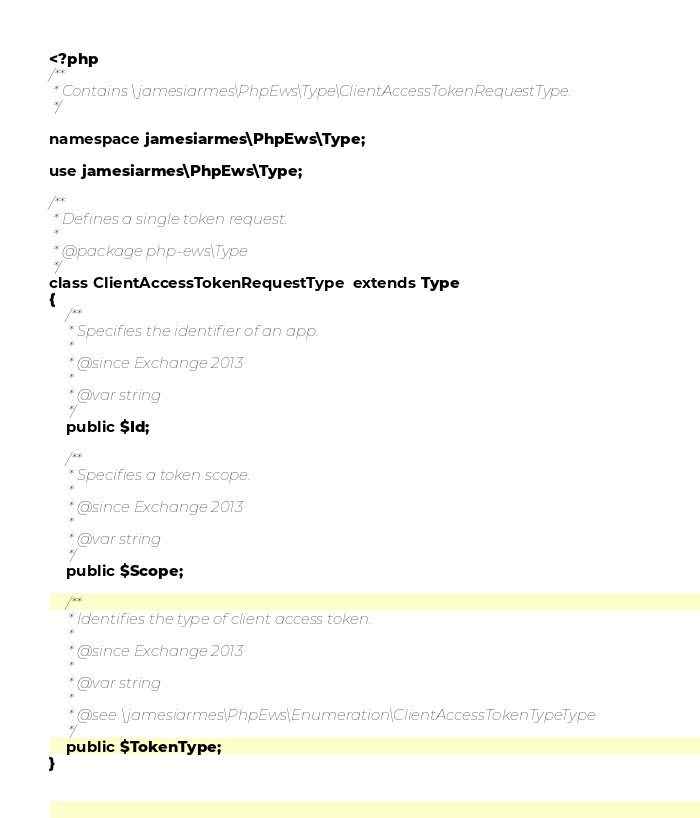<code> <loc_0><loc_0><loc_500><loc_500><_PHP_><?php
/**
 * Contains \jamesiarmes\PhpEws\Type\ClientAccessTokenRequestType.
 */

namespace jamesiarmes\PhpEws\Type;

use jamesiarmes\PhpEws\Type;

/**
 * Defines a single token request.
 *
 * @package php-ews\Type
 */
class ClientAccessTokenRequestType extends Type
{
    /**
     * Specifies the identifier of an app.
     *
     * @since Exchange 2013
     *
     * @var string
     */
    public $Id;

    /**
     * Specifies a token scope.
     *
     * @since Exchange 2013
     *
     * @var string
     */
    public $Scope;

    /**
     * Identifies the type of client access token.
     *
     * @since Exchange 2013
     *
     * @var string
     *
     * @see \jamesiarmes\PhpEws\Enumeration\ClientAccessTokenTypeType
     */
    public $TokenType;
}
</code> 